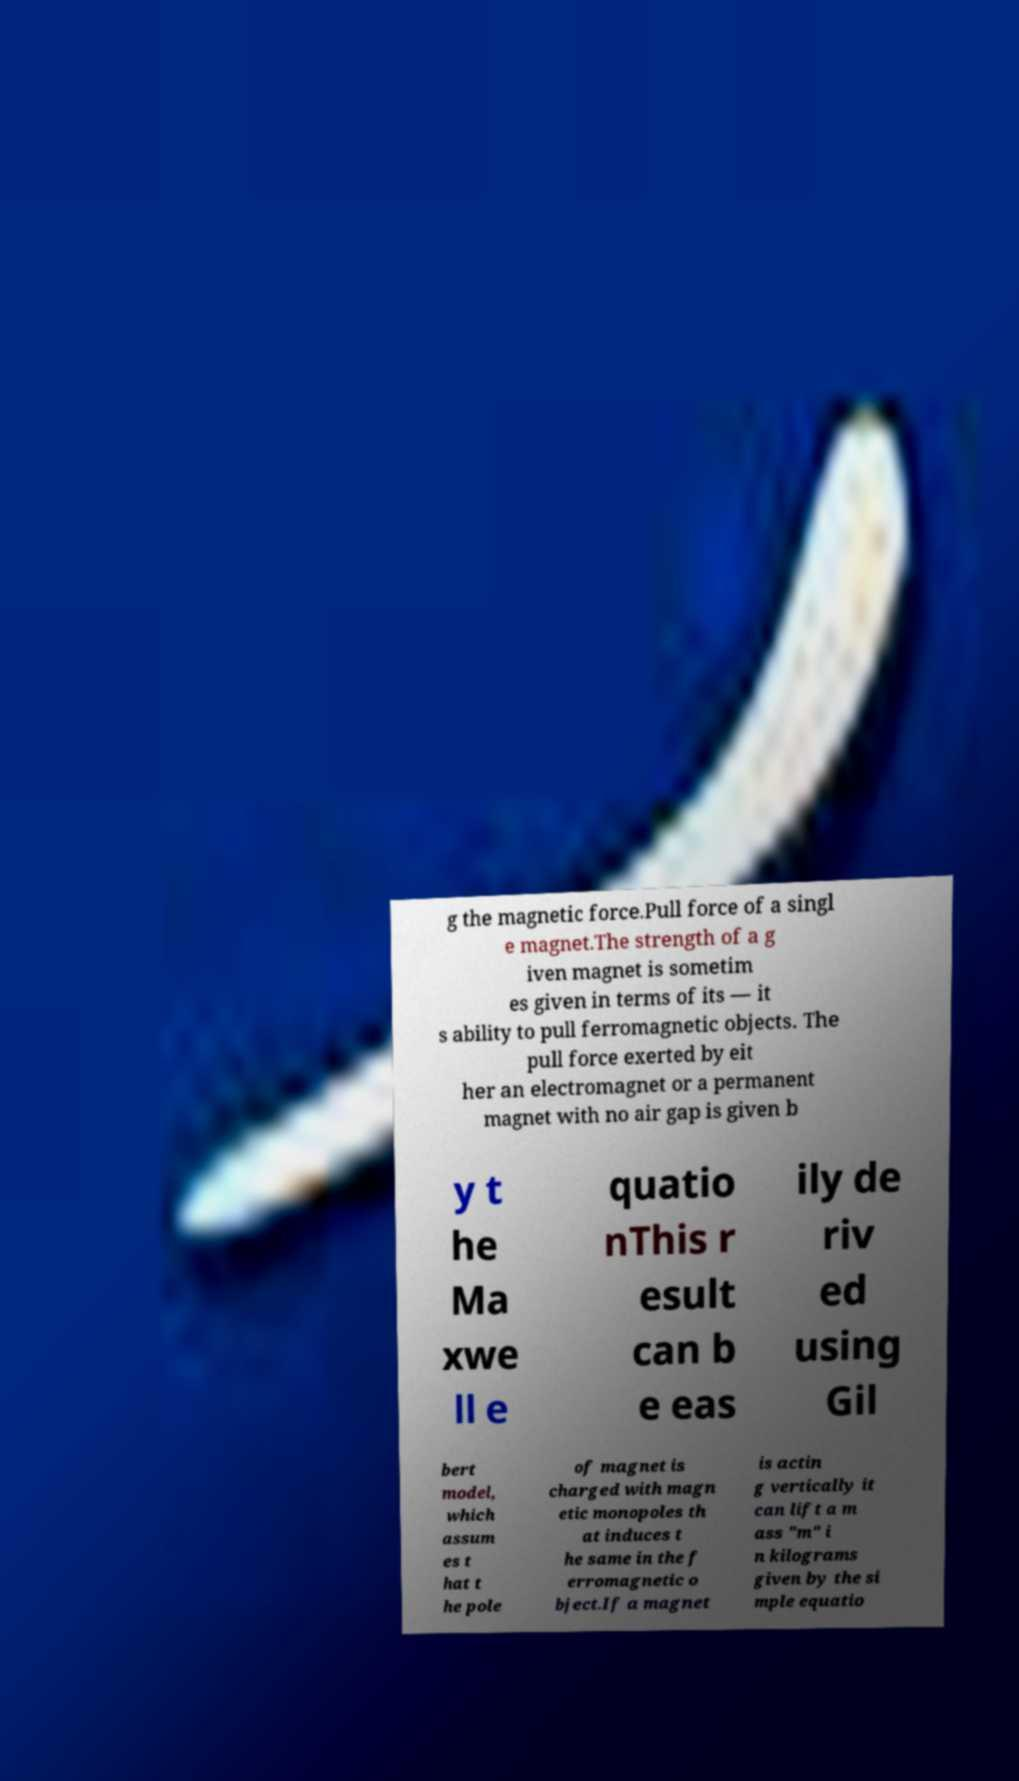Could you assist in decoding the text presented in this image and type it out clearly? g the magnetic force.Pull force of a singl e magnet.The strength of a g iven magnet is sometim es given in terms of its — it s ability to pull ferromagnetic objects. The pull force exerted by eit her an electromagnet or a permanent magnet with no air gap is given b y t he Ma xwe ll e quatio nThis r esult can b e eas ily de riv ed using Gil bert model, which assum es t hat t he pole of magnet is charged with magn etic monopoles th at induces t he same in the f erromagnetic o bject.If a magnet is actin g vertically it can lift a m ass "m" i n kilograms given by the si mple equatio 